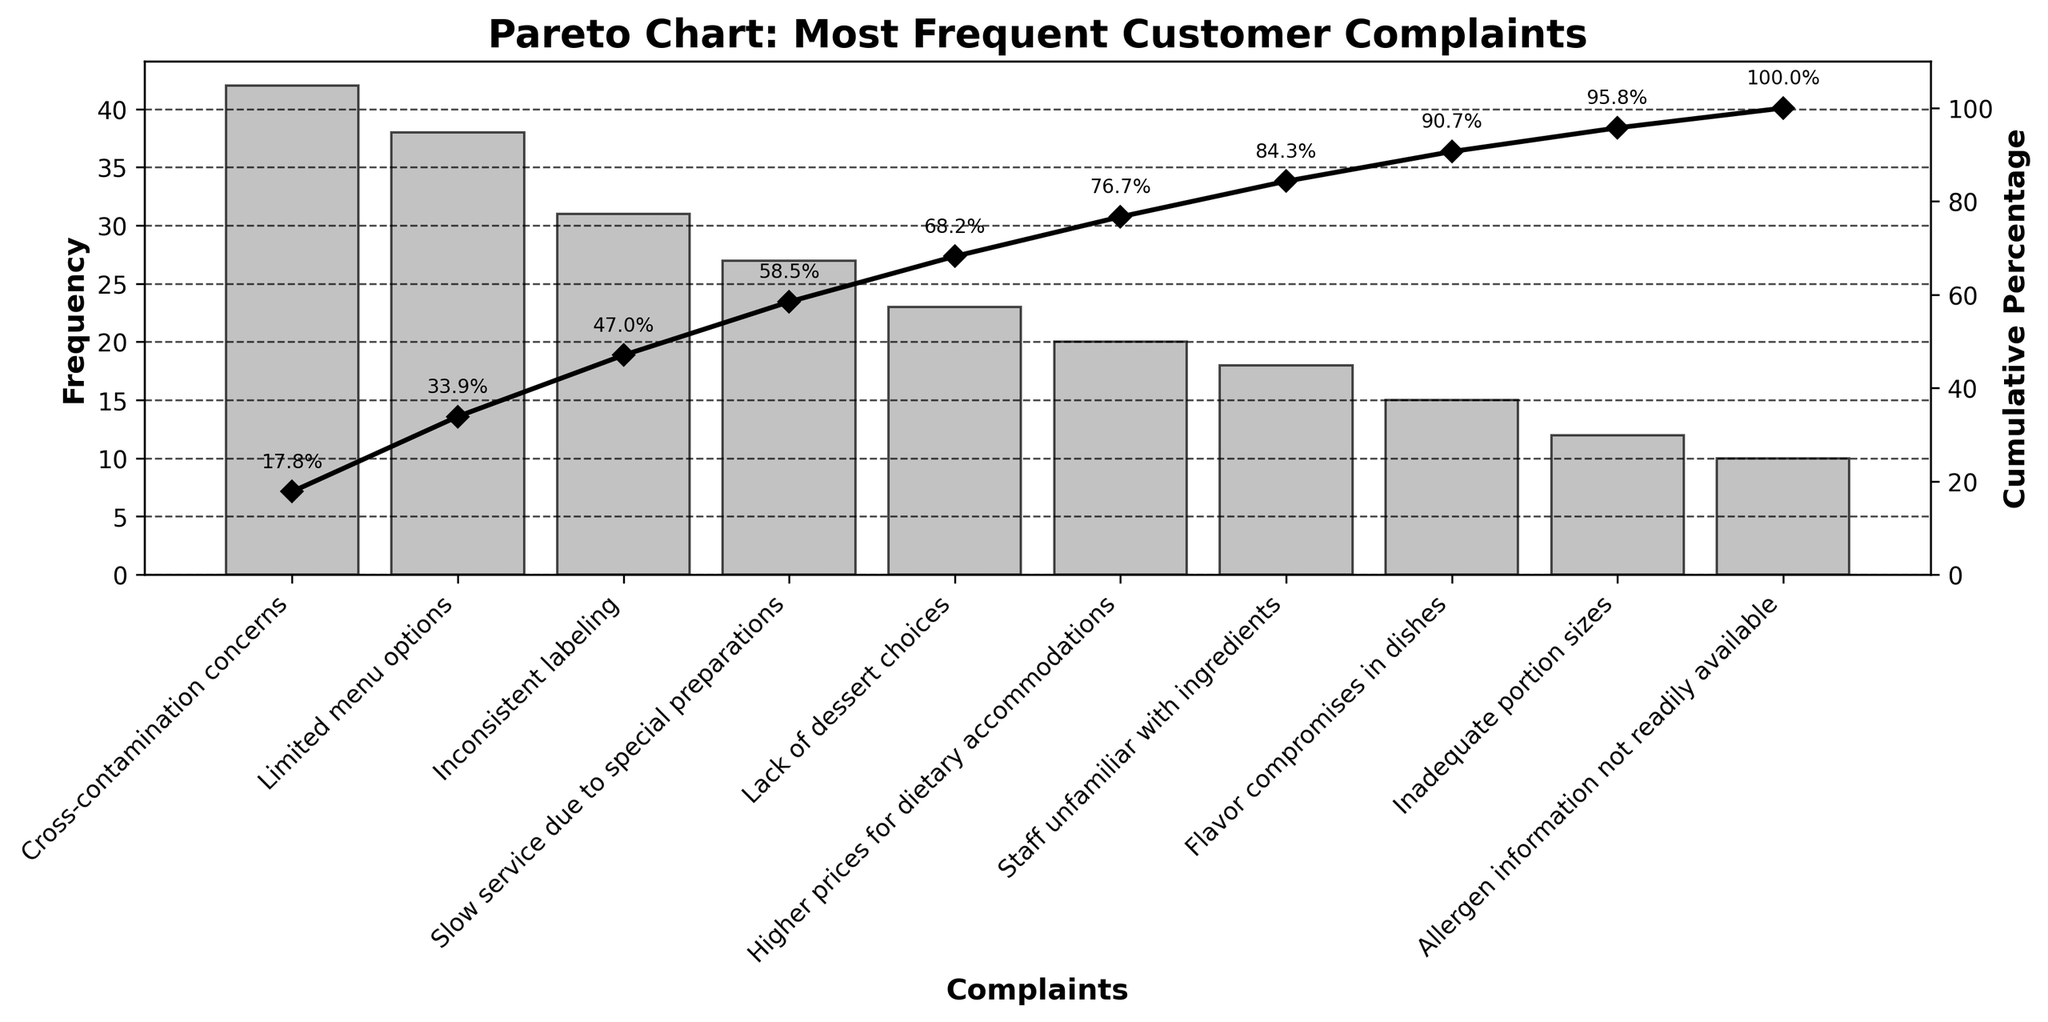What is the title of the chart? The title of the chart is usually placed at the top and can be read directly from the figure.
Answer: Pareto Chart: Most Frequent Customer Complaints How many complaints have a frequency higher than 30? By checking the bars in the chart, you can see which ones surpass the mark of 30 on the frequency axis.
Answer: 3 Which complaint has the highest frequency? The highest bar indicates the complaint with the highest frequency. You can read the corresponding label on the x-axis.
Answer: Cross-contamination concerns What is the cumulative percentage for the top three complaints? Add the individual frequencies of the top three complaints to get a total, then look at the cumulative percentage value at the third position on the cumulative line plot.
Answer: 63.2% Is "Slow service due to special preparations" a more frequent complaint than "Inconsistent labeling"? Compare the heights of the bars for both complaints to see which one is taller.
Answer: No What is the cumulative percentage shown at the complaint with the lowest frequency? Check the cumulative line plot point corresponding to the complaint with the shortest bar.
Answer: 100% How many bars represent complaints with frequencies of 20 or more? Count the number of bars that reach the level of 20 or higher on the frequency axis.
Answer: 6 Which complaint has a higher frequency: "Flavor compromises in dishes" or "Staff unfamiliar with ingredients"? Compare the heights of the bars representing both complaints.
Answer: Staff unfamiliar with ingredients At which complaint does the cumulative percentage reach just above 50%? Look along the cumulative line plot to find the point where it crosses over 50%, then identify the corresponding complaint.
Answer: Limited menu options If you combine the frequencies of "Lack of dessert choices" and "Higher prices for dietary accommodations," what is their total? Sum the frequencies of these two complaints directly from their respective bars.
Answer: 43 Comparing the total frequencies of the bottom five complaints, what is their combined frequency? Add the frequencies of the bottom five complaints from the x-axis.
Answer: 75 